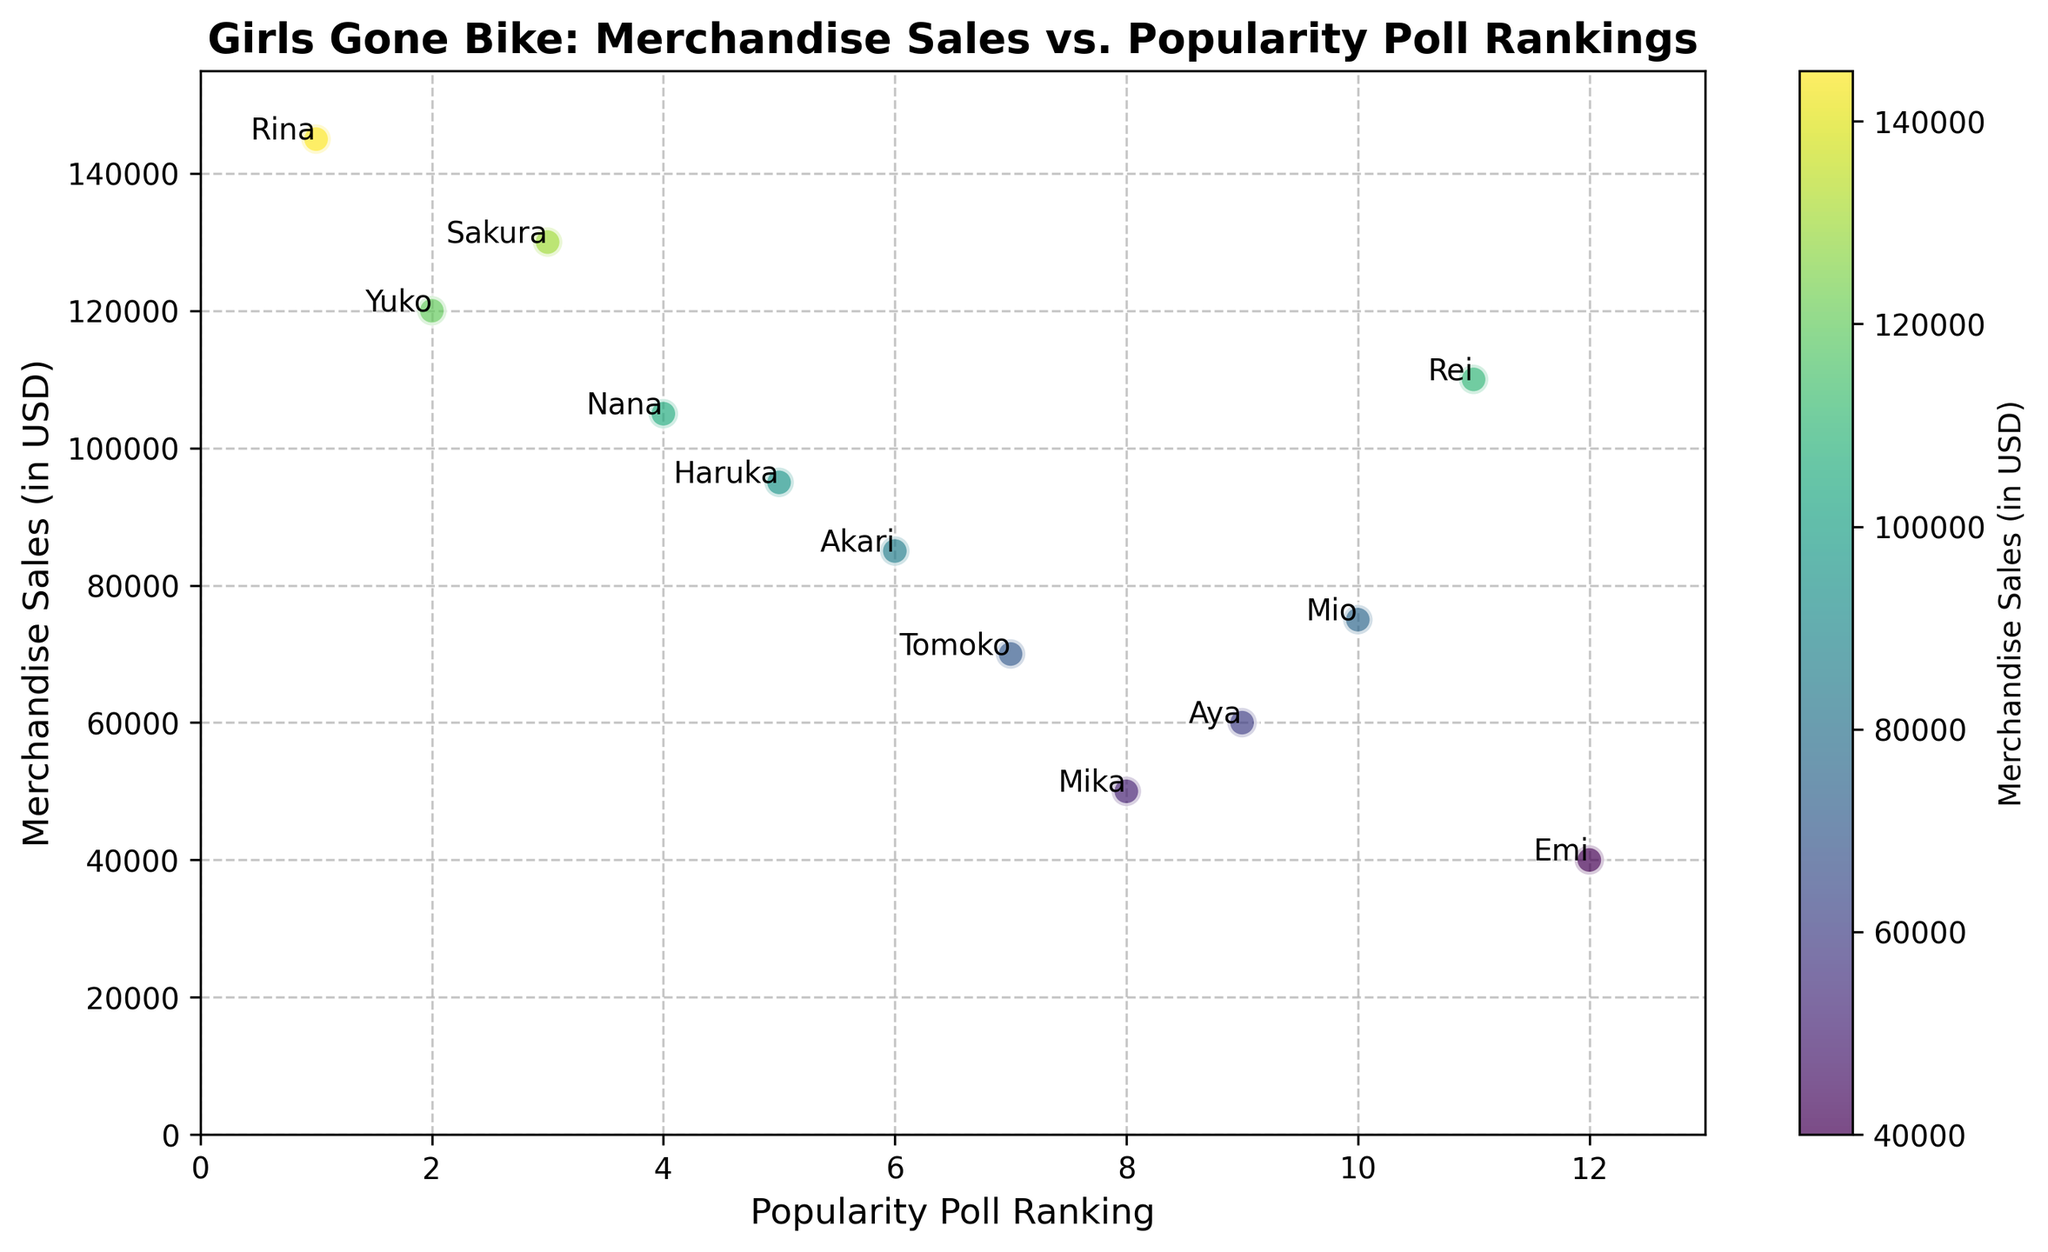Which character has the highest merchandise sales? Look for the character with the highest "Merchandise Sales" value on the y-axis. The highest sales amount is $145,000 which corresponds to the character "Rina".
Answer: Rina Which character ranks 5th in popularity poll? Find the character that has a "Popularity Poll Ranking" value of 5 on the x-axis and check the corresponding label. The label next to ranking 5 is "Haruka".
Answer: Haruka Who has higher merchandise sales: Sakura or Mio? Locate the sales values for both Sakura and Mio on the y-axis. Sakura has sales of $130,000 and Mio has sales of $75,000. Compare these values.
Answer: Sakura What is the average merchandise sales for characters in the top 3 popularity poll rankings? Sum up the sales of the characters ranked 1, 2, and 3, and then divide by 3. Rina (1st) has $145,000, Yuko (2nd) has $120,000, and Sakura (3rd) has $130,000. The sum is $395,000, and the average is $395,000 / 3.
Answer: $131,666.67 Which character has the lowest popularity and what are their merchandise sales? Locate the character with the highest "Popularity Poll Ranking" value, since the ranking starts from 1. The character with the highest rank, which is 12, is "Emi". The merchandise sales of Emi are $40,000.
Answer: Emi with $40,000 How much more merchandise sales does Rina have compared to Rei? Find the merchandise sales values for Rina and Rei and then subtract Rei's sales from Rina's sales. Rina has $145,000 and Rei has $110,000. So, $145,000 - $110,000 = $35,000.
Answer: $35,000 Which character's sales are closest to $100,000? Look for the character whose sales value on the y-axis is nearest to $100,000. The closest is Nana with $105,000.
Answer: Nana Rank the characters by their merchandise sales from highest to lowest. Find the merchandise sales values for all characters and order them from highest to lowest. The ordered characters are: Rina, Sakura, Yuko, Nana, Rei, Haruka, Akari, Mio, Tomoko, Aya, Mika, Emi.
Answer: Rina, Sakura, Yuko, Nana, Rei, Haruka, Akari, Mio, Tomoko, Aya, Mika, Emi Do higher poll rankings generally correlate with higher merchandise sales? Observe if characters with lower popularity ranks (closer to 1) tend to have higher sales values. Generally, characters with better poll rankings (like Rina, Yuko, and Sakura) have higher sales.
Answer: Yes 